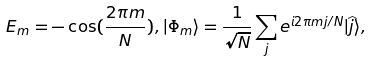<formula> <loc_0><loc_0><loc_500><loc_500>E _ { m } = - \cos ( \frac { 2 \pi m } { N } ) , | \Phi _ { m } \rangle = \frac { 1 } { \sqrt { N } } \sum _ { j } { e ^ { i 2 \pi m j / N } | \widehat { j } \rangle } ,</formula> 